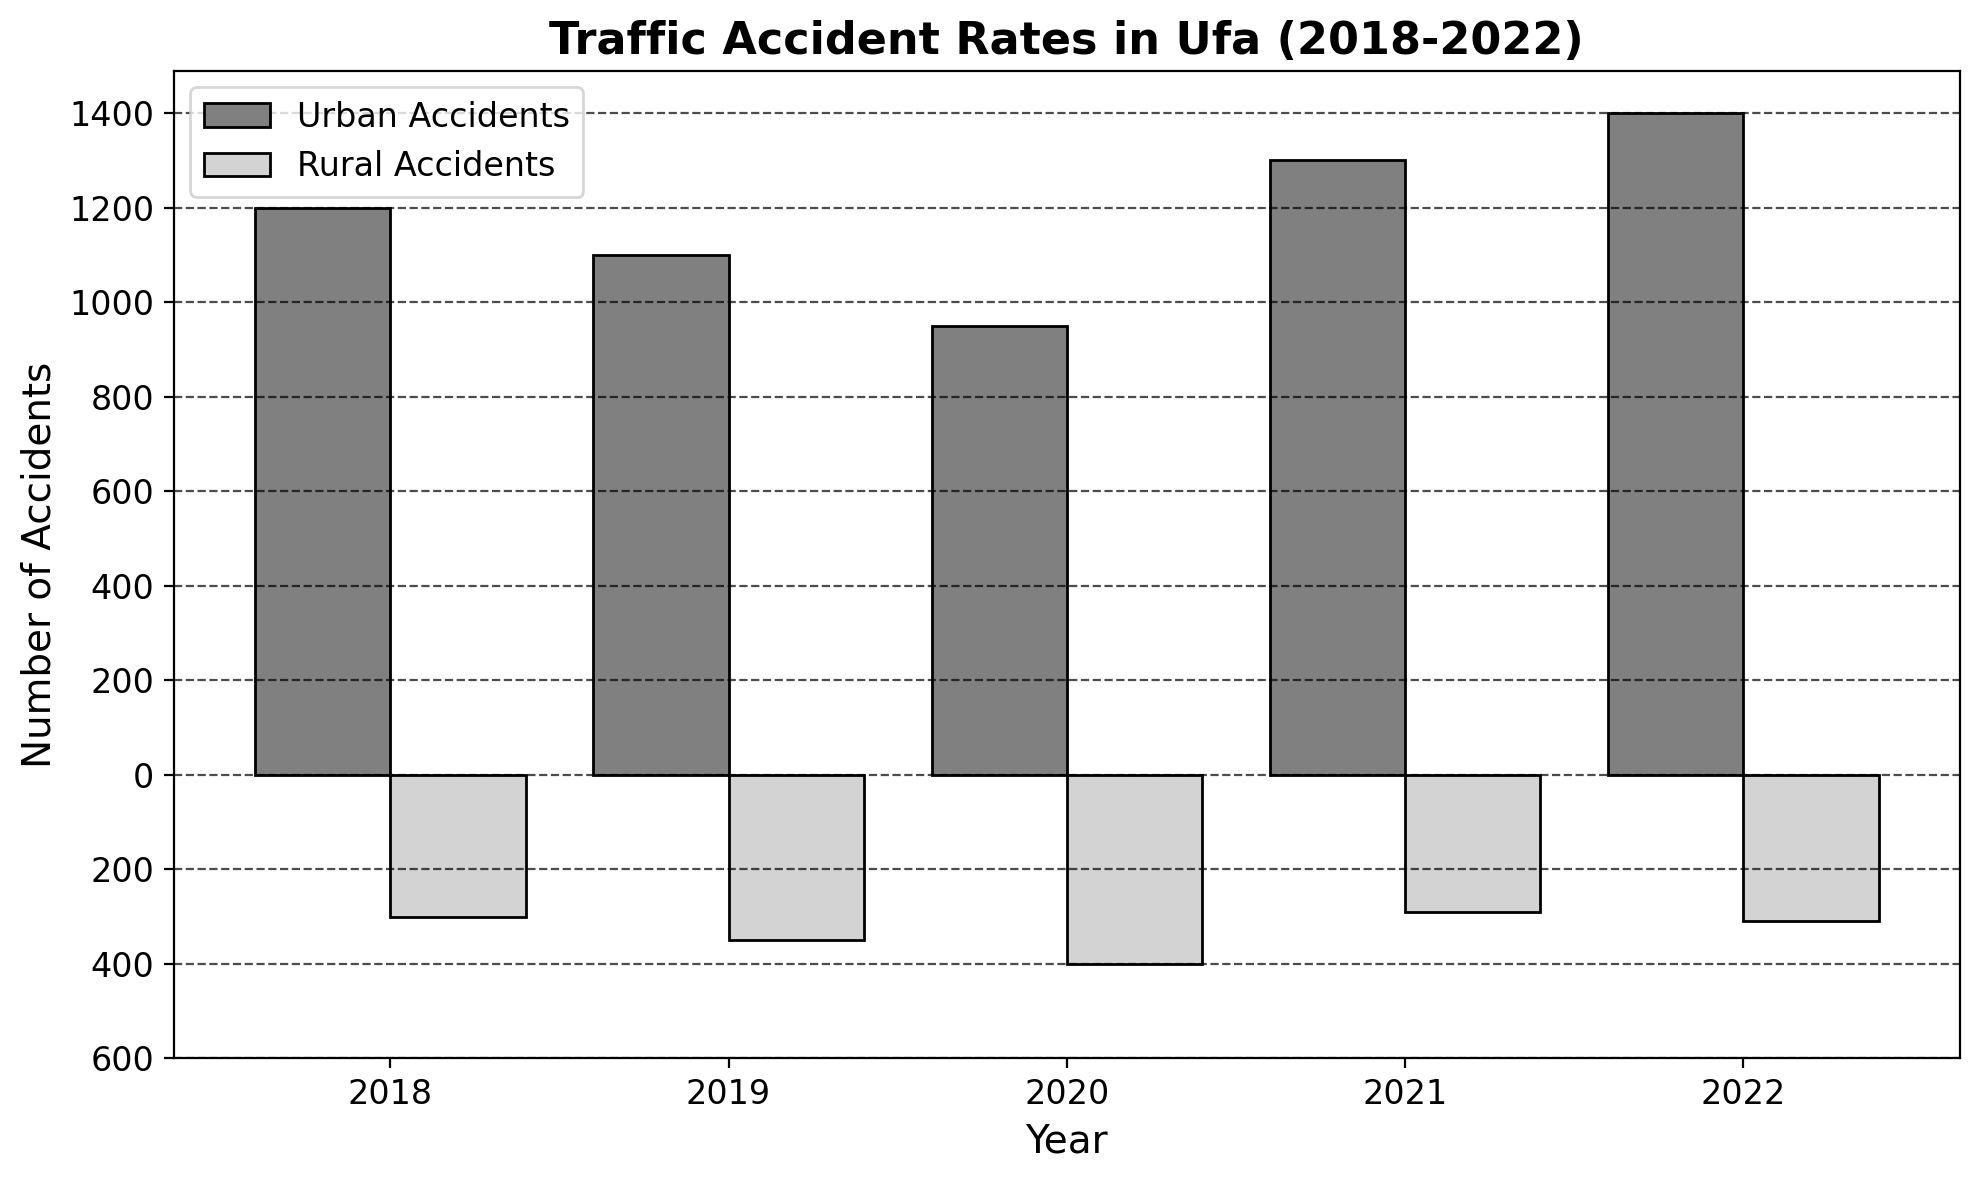What is the total number of urban accidents in 2022? We look at the bar representing the year 2022 on the positive side of the y-axis. The height of the bar indicates the number of urban accidents, which is 1400.
Answer: 1400 How did urban accident rates change from 2018 to 2022? We compare the heights of the bars for urban accidents from 2018 to 2022. In 2018, there were 1200 accidents and this increased to 1400 by 2022.
Answer: Increased What was the trend in rural accident rates between 2019 and 2021? We observe the bars for rural accidents from 2019 to 2021. The height of the bars shows that accidents were 350 in 2019, 400 in 2020, and decreased to 290 in 2021.
Answer: Increased, then decreased Which year had the highest number of rural accidents? We find the deepest negative bar on the chart. The year with the highest number of rural accidents is the one with the bar at the lowest point, which is 2020 with a value of 400.
Answer: 2020 What is the difference in the number of urban and rural accidents in 2021? We look at the bars for 2021. The urban accidents bar is at 1300 and the rural accidents bar is at -290. The difference is 1300 - 290.
Answer: 1010 In which year were urban accidents the lowest? We scan the heights of the bars representing urban accidents across all years and find that the shortest bar is for the year 2020, indicating 950 accidents.
Answer: 2020 What is the average number of urban accidents per year over the five-year period? We calculate the average by summing the urban accidents for each year and dividing by the number of years: (1200 + 1100 + 950 + 1300 + 1400) / 5 = 1190.
Answer: 1190 In which year did rural accidents see the biggest numerical increase from the previous year? We calculate the yearly differences: 
   2019-2018: 350-300 = 50
   2020-2019: 400-350 = 50
   2021-2020: 290-400 = -110 
   2022-2021: 310-290 = 20 
   Both 2019 and 2020 have the highest increase of 50.
Answer: 2019 and 2020 